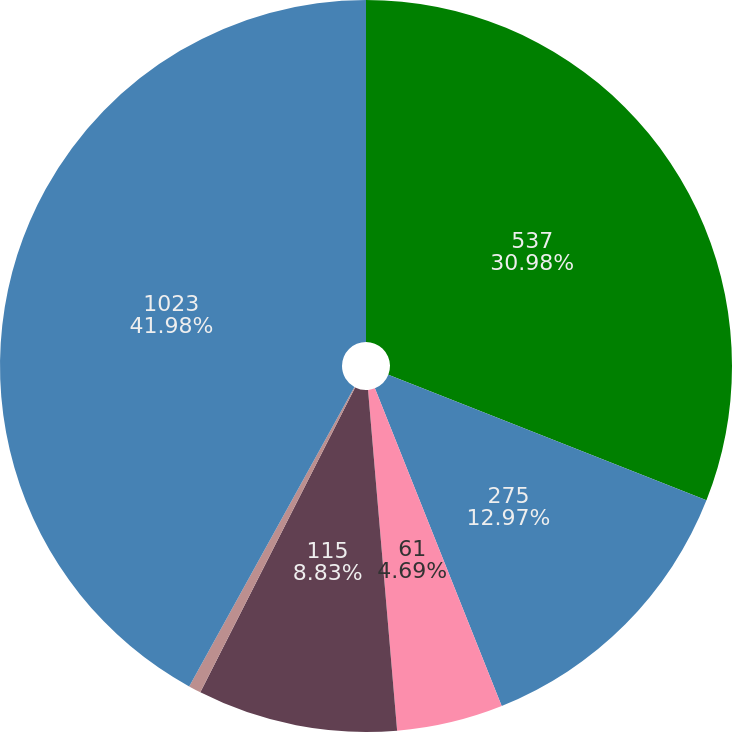Convert chart. <chart><loc_0><loc_0><loc_500><loc_500><pie_chart><fcel>537<fcel>275<fcel>61<fcel>115<fcel>35<fcel>1023<nl><fcel>30.98%<fcel>12.97%<fcel>4.69%<fcel>8.83%<fcel>0.55%<fcel>41.97%<nl></chart> 